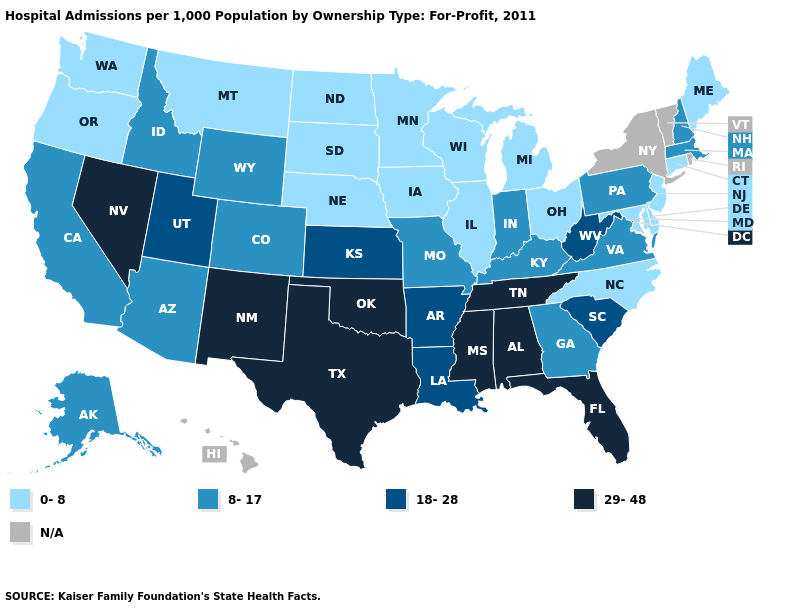Among the states that border Washington , which have the lowest value?
Keep it brief. Oregon. Among the states that border New York , does Pennsylvania have the highest value?
Concise answer only. Yes. Does Mississippi have the lowest value in the South?
Be succinct. No. Which states have the lowest value in the South?
Short answer required. Delaware, Maryland, North Carolina. Name the states that have a value in the range N/A?
Give a very brief answer. Hawaii, New York, Rhode Island, Vermont. What is the value of Georgia?
Be succinct. 8-17. Name the states that have a value in the range 0-8?
Give a very brief answer. Connecticut, Delaware, Illinois, Iowa, Maine, Maryland, Michigan, Minnesota, Montana, Nebraska, New Jersey, North Carolina, North Dakota, Ohio, Oregon, South Dakota, Washington, Wisconsin. Name the states that have a value in the range N/A?
Be succinct. Hawaii, New York, Rhode Island, Vermont. What is the value of Wyoming?
Be succinct. 8-17. Among the states that border Mississippi , which have the lowest value?
Concise answer only. Arkansas, Louisiana. Name the states that have a value in the range 18-28?
Answer briefly. Arkansas, Kansas, Louisiana, South Carolina, Utah, West Virginia. Name the states that have a value in the range 0-8?
Quick response, please. Connecticut, Delaware, Illinois, Iowa, Maine, Maryland, Michigan, Minnesota, Montana, Nebraska, New Jersey, North Carolina, North Dakota, Ohio, Oregon, South Dakota, Washington, Wisconsin. What is the highest value in the Northeast ?
Be succinct. 8-17. Does Nevada have the highest value in the USA?
Answer briefly. Yes. Does North Carolina have the lowest value in the USA?
Quick response, please. Yes. 